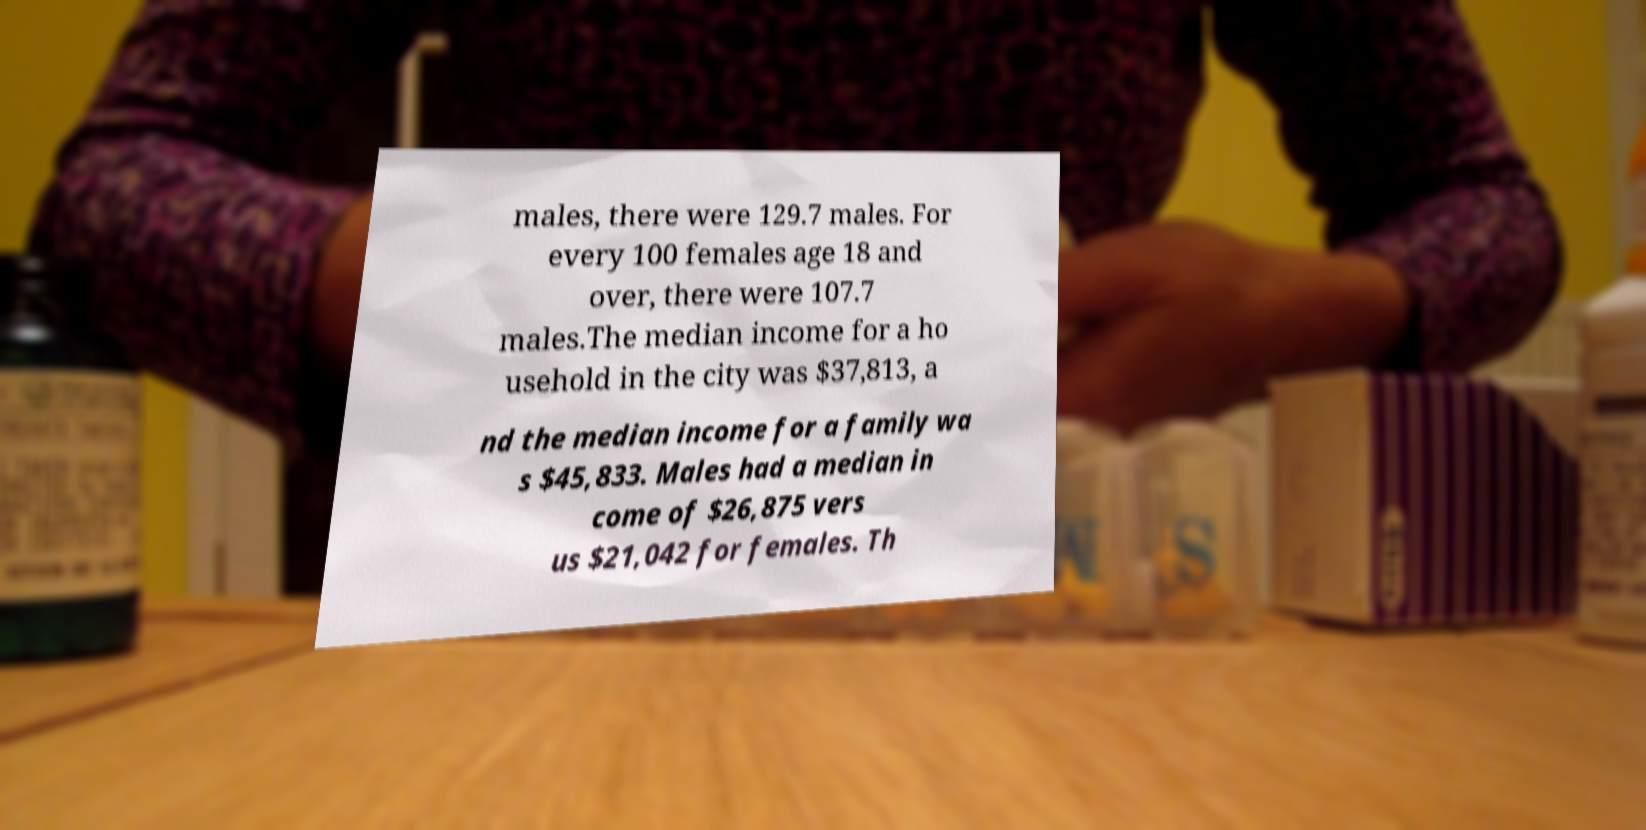Can you read and provide the text displayed in the image?This photo seems to have some interesting text. Can you extract and type it out for me? males, there were 129.7 males. For every 100 females age 18 and over, there were 107.7 males.The median income for a ho usehold in the city was $37,813, a nd the median income for a family wa s $45,833. Males had a median in come of $26,875 vers us $21,042 for females. Th 